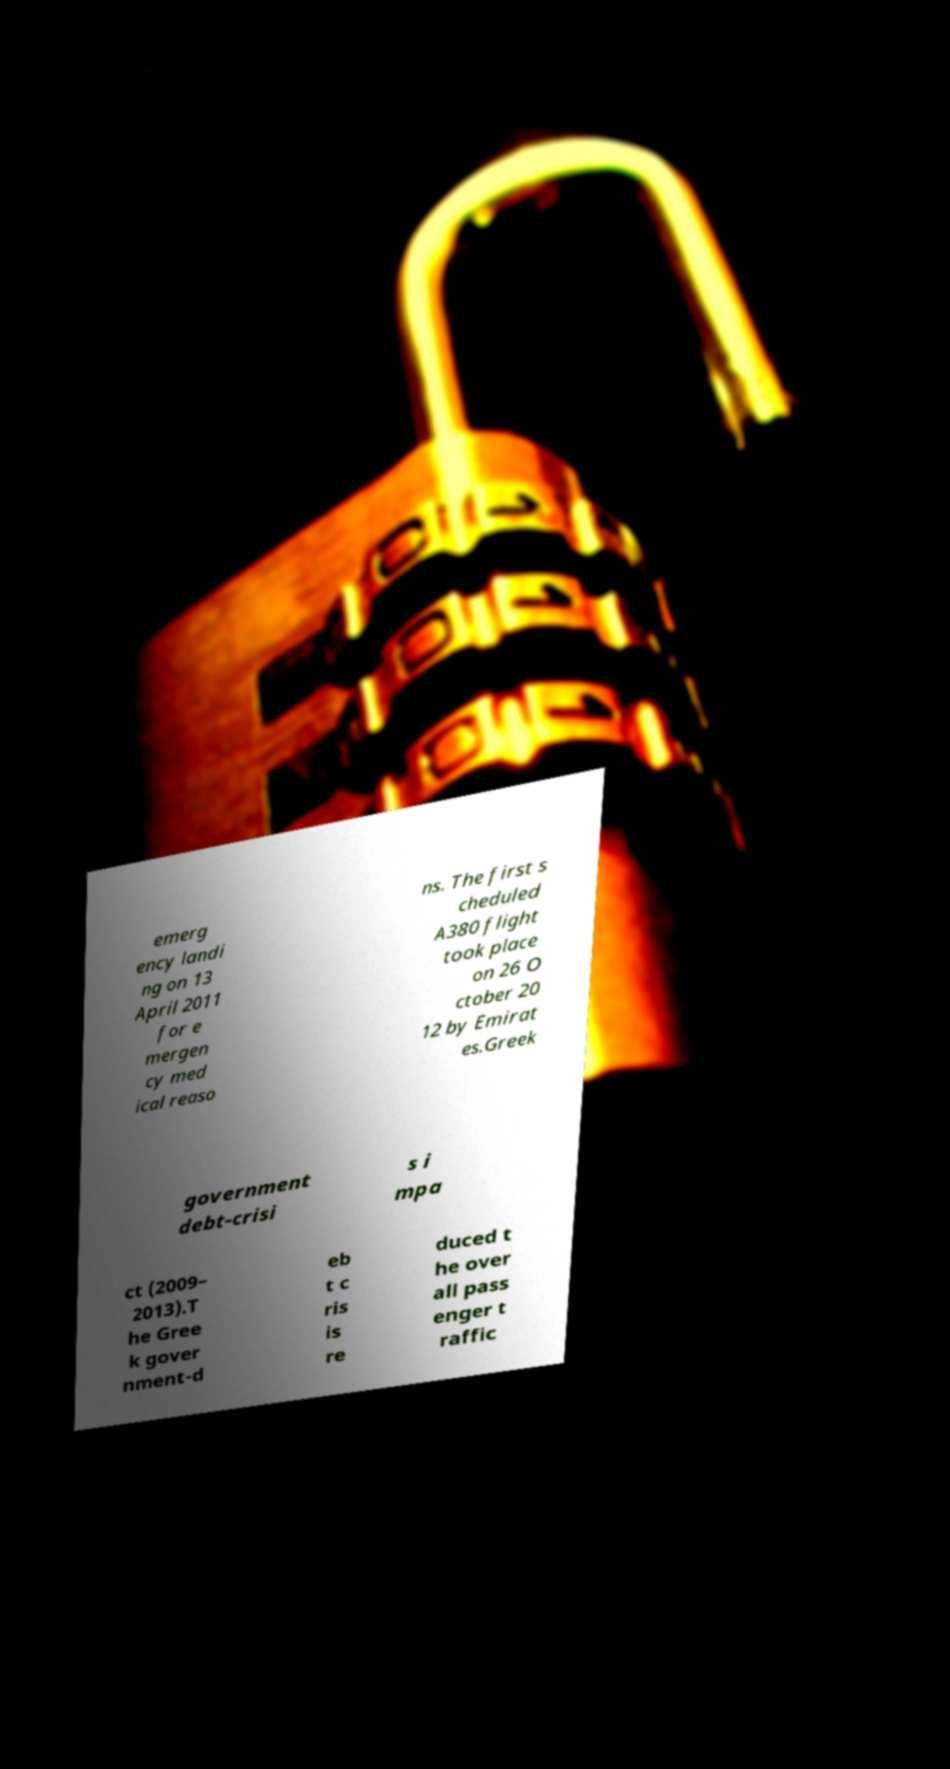Could you extract and type out the text from this image? emerg ency landi ng on 13 April 2011 for e mergen cy med ical reaso ns. The first s cheduled A380 flight took place on 26 O ctober 20 12 by Emirat es.Greek government debt-crisi s i mpa ct (2009– 2013).T he Gree k gover nment-d eb t c ris is re duced t he over all pass enger t raffic 